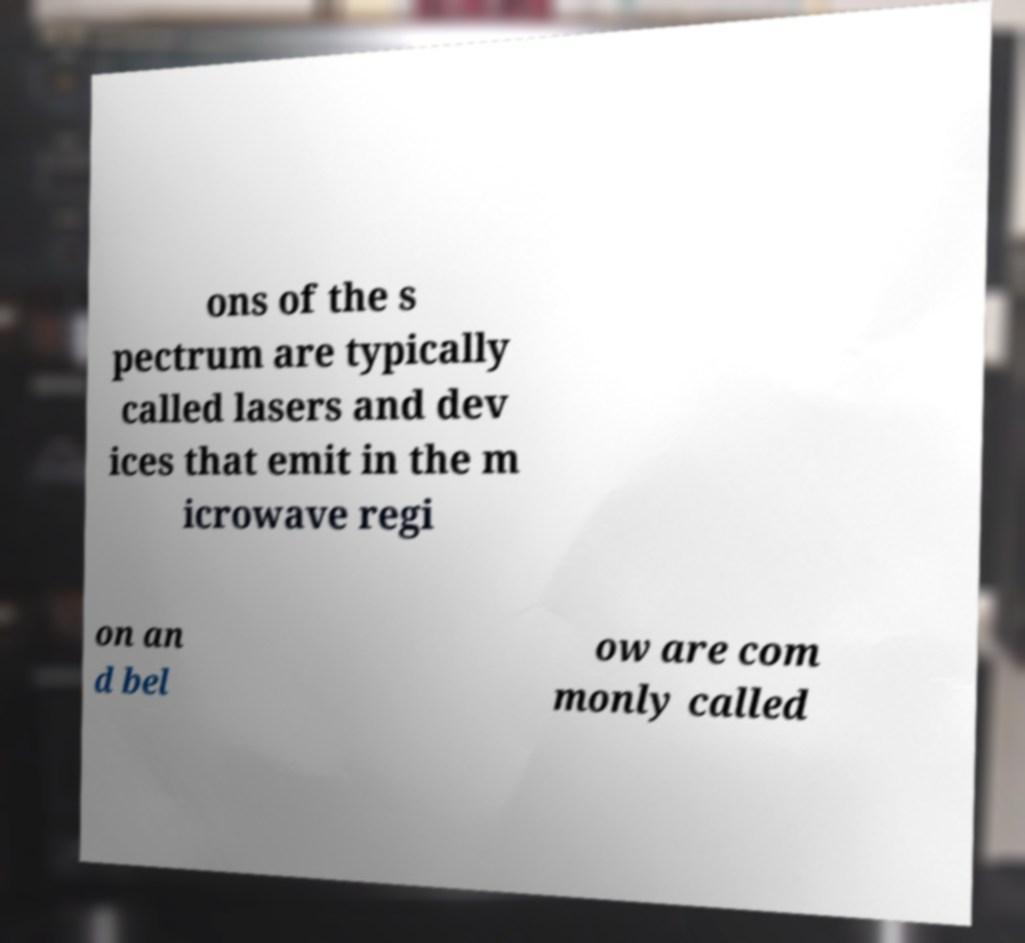I need the written content from this picture converted into text. Can you do that? ons of the s pectrum are typically called lasers and dev ices that emit in the m icrowave regi on an d bel ow are com monly called 